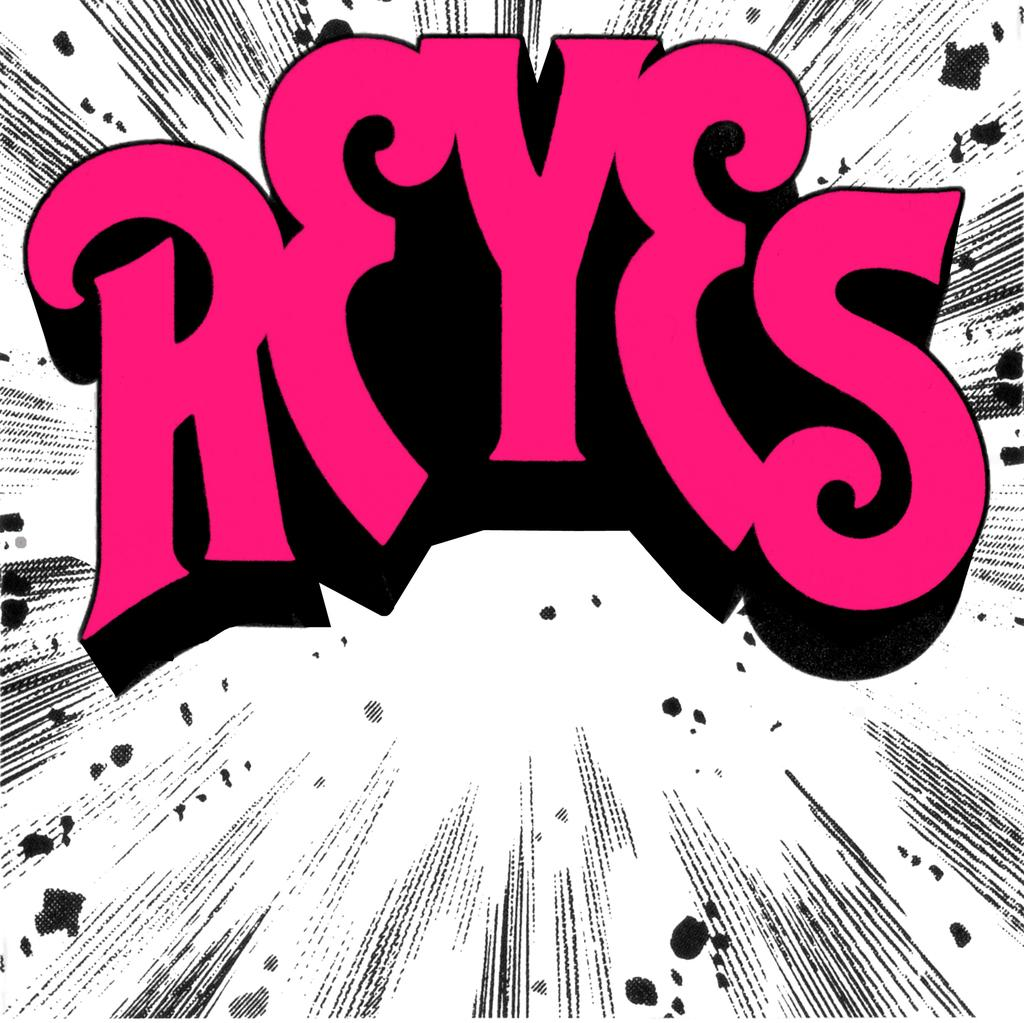<image>
Relay a brief, clear account of the picture shown. A white sign that reads Reyes in pink letters 